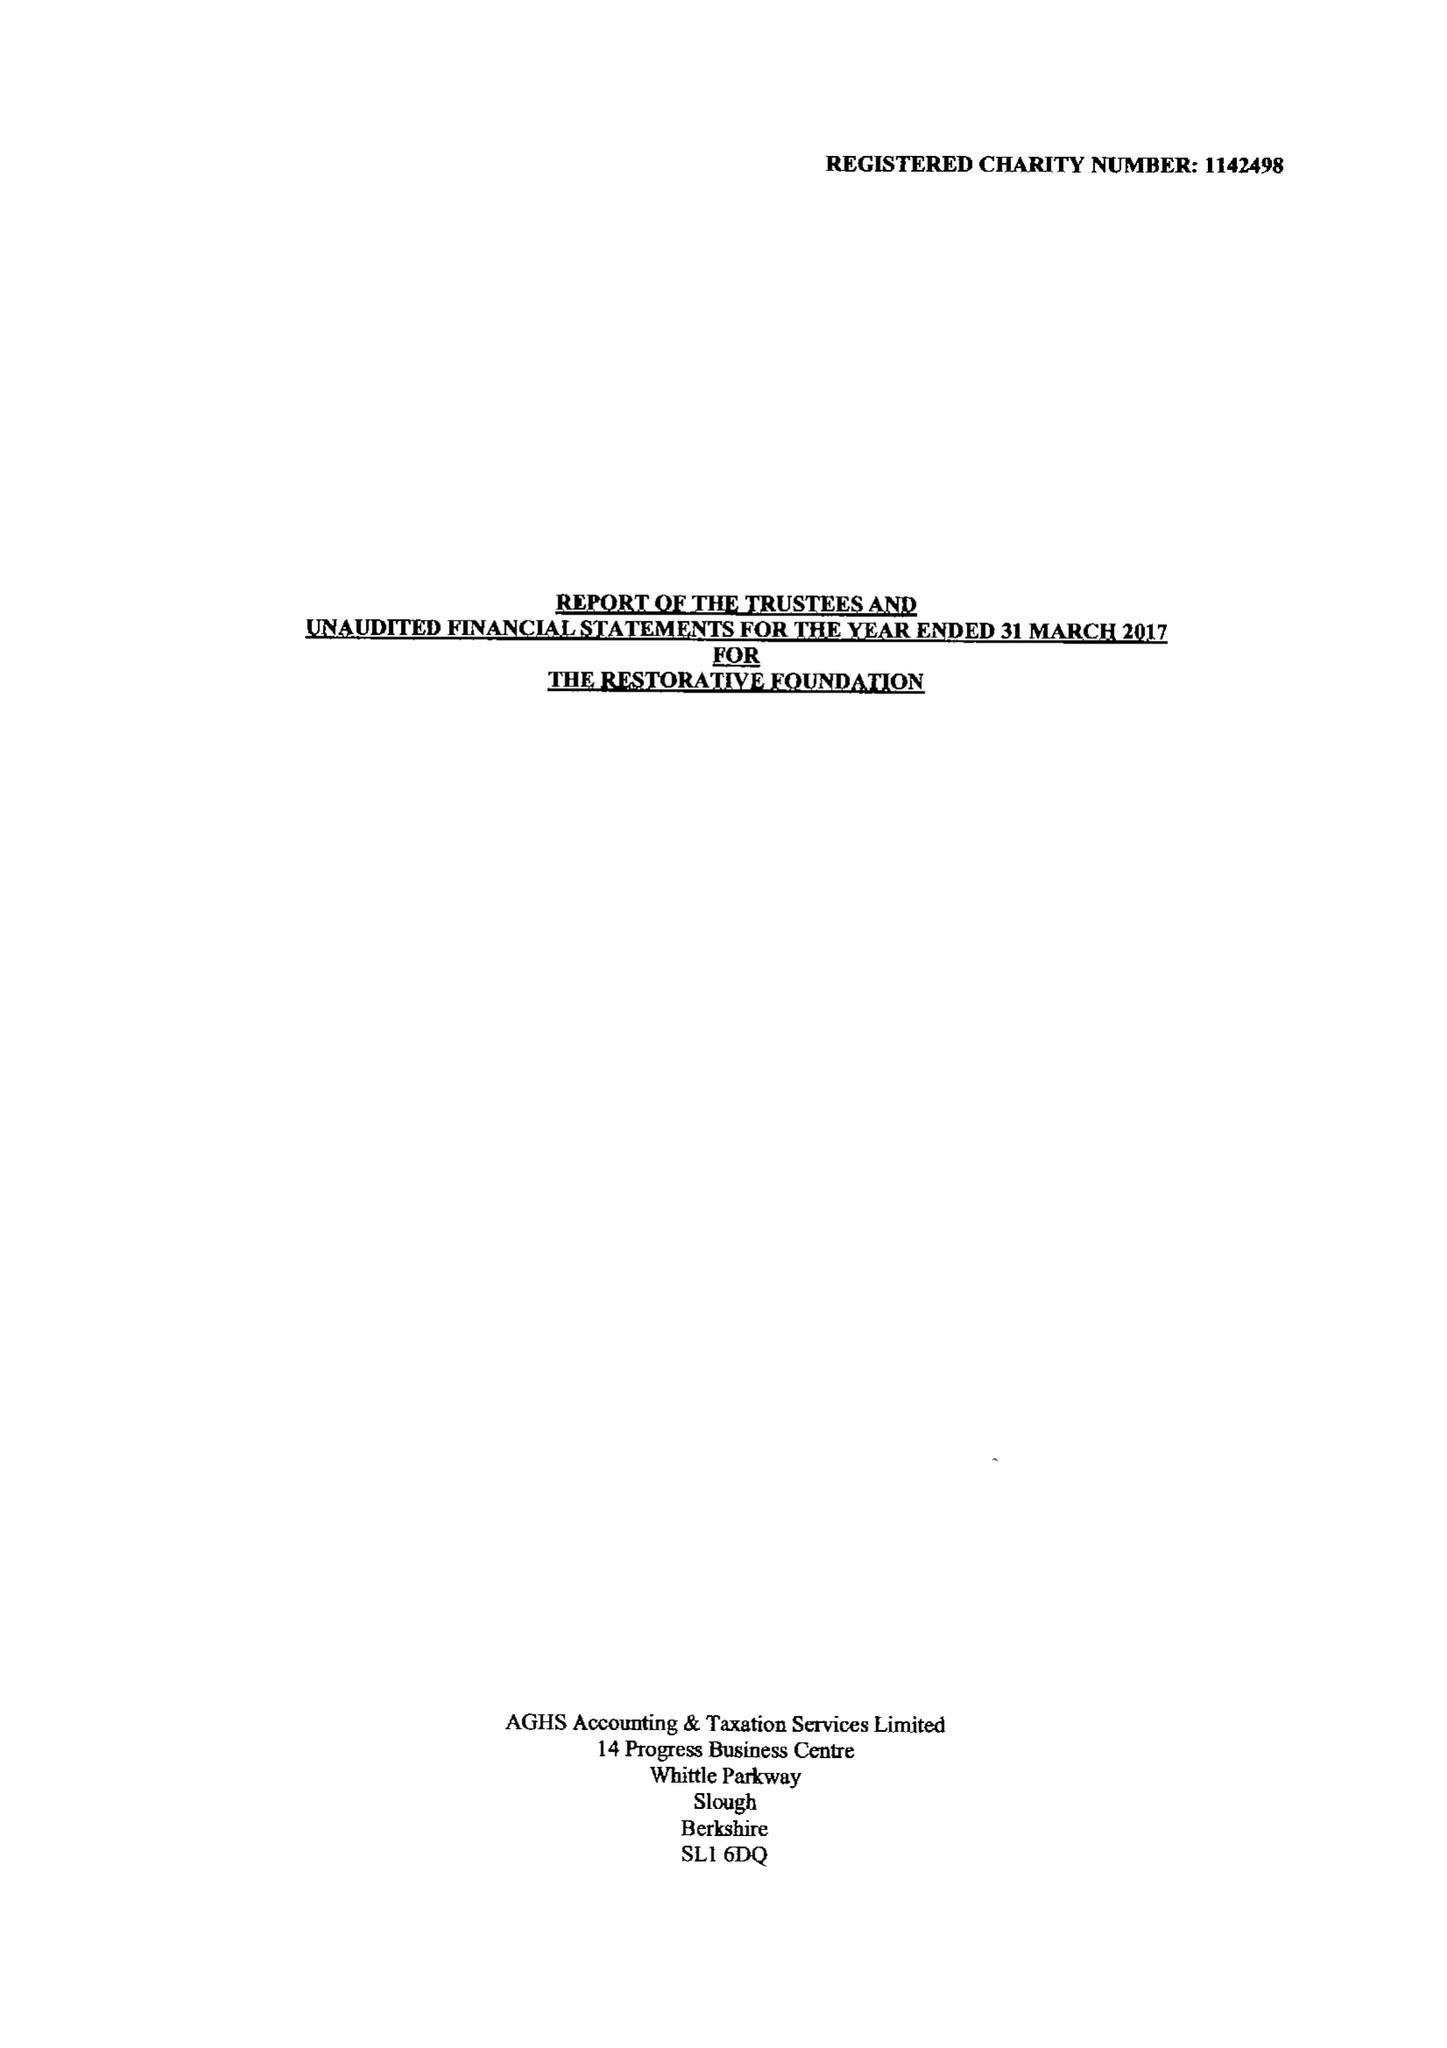What is the value for the income_annually_in_british_pounds?
Answer the question using a single word or phrase. 49185.00 